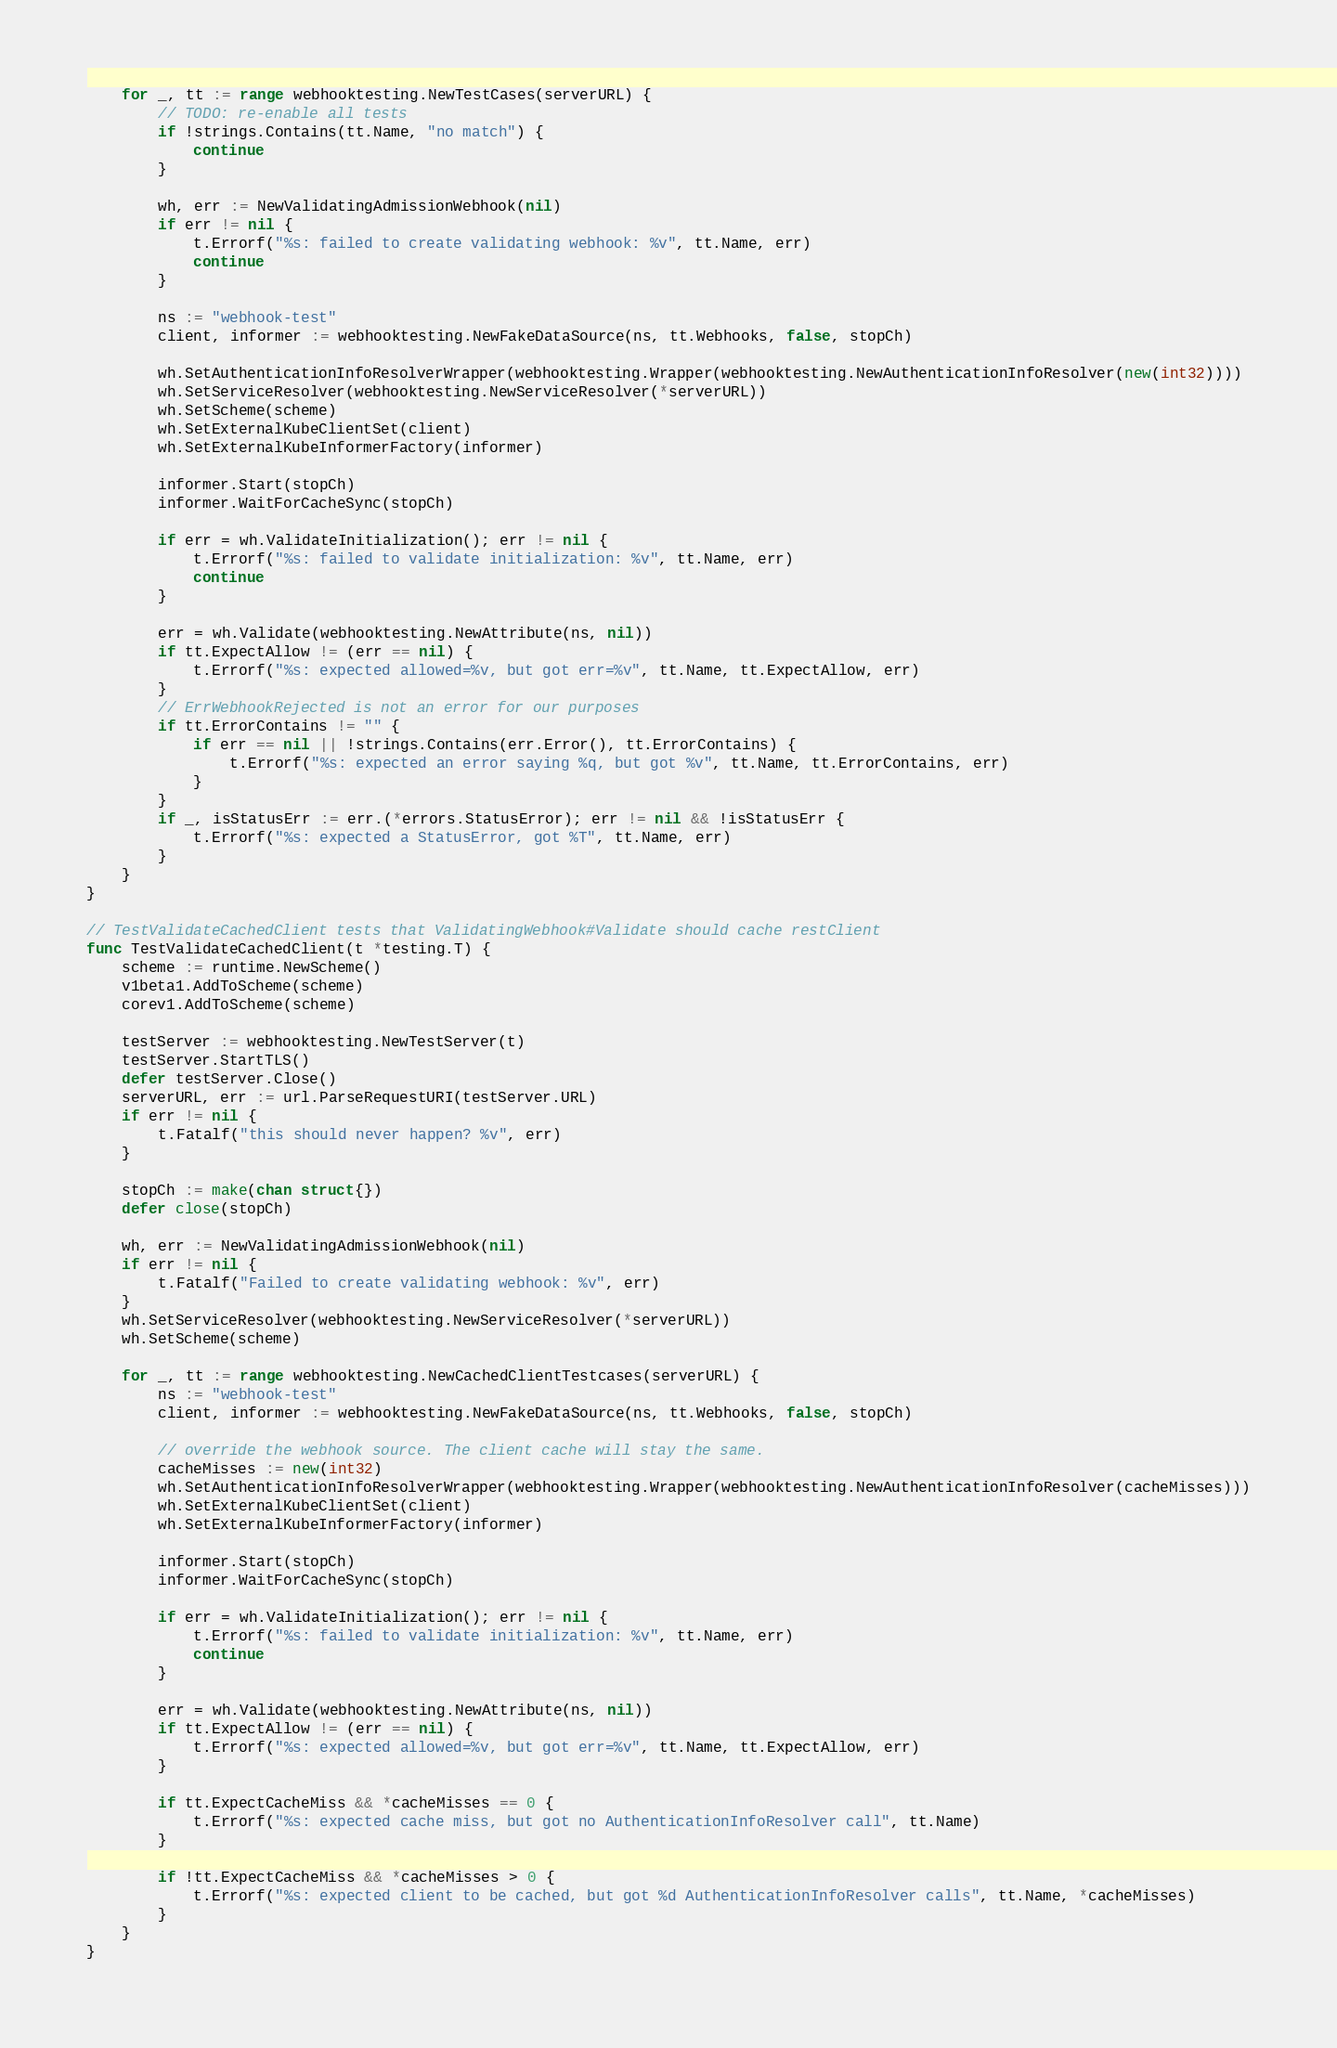<code> <loc_0><loc_0><loc_500><loc_500><_Go_>
	for _, tt := range webhooktesting.NewTestCases(serverURL) {
		// TODO: re-enable all tests
		if !strings.Contains(tt.Name, "no match") {
			continue
		}

		wh, err := NewValidatingAdmissionWebhook(nil)
		if err != nil {
			t.Errorf("%s: failed to create validating webhook: %v", tt.Name, err)
			continue
		}

		ns := "webhook-test"
		client, informer := webhooktesting.NewFakeDataSource(ns, tt.Webhooks, false, stopCh)

		wh.SetAuthenticationInfoResolverWrapper(webhooktesting.Wrapper(webhooktesting.NewAuthenticationInfoResolver(new(int32))))
		wh.SetServiceResolver(webhooktesting.NewServiceResolver(*serverURL))
		wh.SetScheme(scheme)
		wh.SetExternalKubeClientSet(client)
		wh.SetExternalKubeInformerFactory(informer)

		informer.Start(stopCh)
		informer.WaitForCacheSync(stopCh)

		if err = wh.ValidateInitialization(); err != nil {
			t.Errorf("%s: failed to validate initialization: %v", tt.Name, err)
			continue
		}

		err = wh.Validate(webhooktesting.NewAttribute(ns, nil))
		if tt.ExpectAllow != (err == nil) {
			t.Errorf("%s: expected allowed=%v, but got err=%v", tt.Name, tt.ExpectAllow, err)
		}
		// ErrWebhookRejected is not an error for our purposes
		if tt.ErrorContains != "" {
			if err == nil || !strings.Contains(err.Error(), tt.ErrorContains) {
				t.Errorf("%s: expected an error saying %q, but got %v", tt.Name, tt.ErrorContains, err)
			}
		}
		if _, isStatusErr := err.(*errors.StatusError); err != nil && !isStatusErr {
			t.Errorf("%s: expected a StatusError, got %T", tt.Name, err)
		}
	}
}

// TestValidateCachedClient tests that ValidatingWebhook#Validate should cache restClient
func TestValidateCachedClient(t *testing.T) {
	scheme := runtime.NewScheme()
	v1beta1.AddToScheme(scheme)
	corev1.AddToScheme(scheme)

	testServer := webhooktesting.NewTestServer(t)
	testServer.StartTLS()
	defer testServer.Close()
	serverURL, err := url.ParseRequestURI(testServer.URL)
	if err != nil {
		t.Fatalf("this should never happen? %v", err)
	}

	stopCh := make(chan struct{})
	defer close(stopCh)

	wh, err := NewValidatingAdmissionWebhook(nil)
	if err != nil {
		t.Fatalf("Failed to create validating webhook: %v", err)
	}
	wh.SetServiceResolver(webhooktesting.NewServiceResolver(*serverURL))
	wh.SetScheme(scheme)

	for _, tt := range webhooktesting.NewCachedClientTestcases(serverURL) {
		ns := "webhook-test"
		client, informer := webhooktesting.NewFakeDataSource(ns, tt.Webhooks, false, stopCh)

		// override the webhook source. The client cache will stay the same.
		cacheMisses := new(int32)
		wh.SetAuthenticationInfoResolverWrapper(webhooktesting.Wrapper(webhooktesting.NewAuthenticationInfoResolver(cacheMisses)))
		wh.SetExternalKubeClientSet(client)
		wh.SetExternalKubeInformerFactory(informer)

		informer.Start(stopCh)
		informer.WaitForCacheSync(stopCh)

		if err = wh.ValidateInitialization(); err != nil {
			t.Errorf("%s: failed to validate initialization: %v", tt.Name, err)
			continue
		}

		err = wh.Validate(webhooktesting.NewAttribute(ns, nil))
		if tt.ExpectAllow != (err == nil) {
			t.Errorf("%s: expected allowed=%v, but got err=%v", tt.Name, tt.ExpectAllow, err)
		}

		if tt.ExpectCacheMiss && *cacheMisses == 0 {
			t.Errorf("%s: expected cache miss, but got no AuthenticationInfoResolver call", tt.Name)
		}

		if !tt.ExpectCacheMiss && *cacheMisses > 0 {
			t.Errorf("%s: expected client to be cached, but got %d AuthenticationInfoResolver calls", tt.Name, *cacheMisses)
		}
	}
}
</code> 